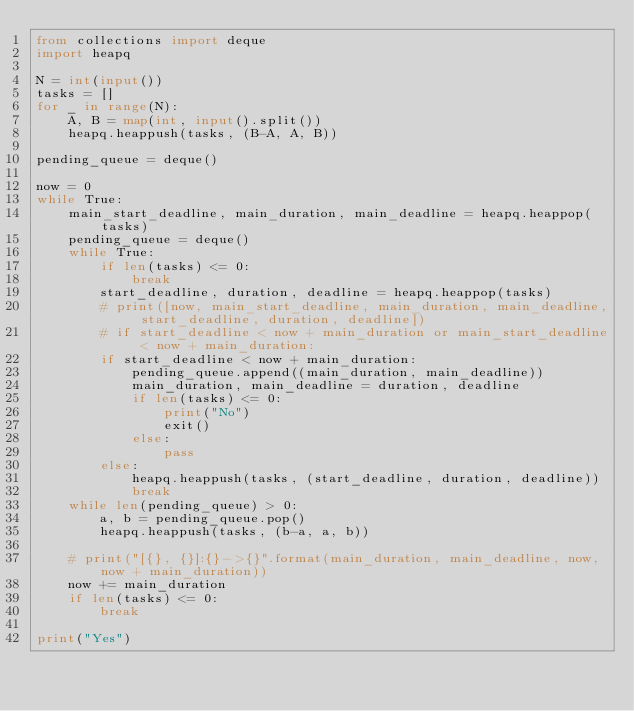<code> <loc_0><loc_0><loc_500><loc_500><_Python_>from collections import deque
import heapq

N = int(input())
tasks = []
for _ in range(N):
    A, B = map(int, input().split())
    heapq.heappush(tasks, (B-A, A, B))

pending_queue = deque()

now = 0
while True:
    main_start_deadline, main_duration, main_deadline = heapq.heappop(tasks)
    pending_queue = deque()
    while True:
        if len(tasks) <= 0:
            break
        start_deadline, duration, deadline = heapq.heappop(tasks)
        # print([now, main_start_deadline, main_duration, main_deadline, start_deadline, duration, deadline])
        # if start_deadline < now + main_duration or main_start_deadline < now + main_duration:
        if start_deadline < now + main_duration:
            pending_queue.append((main_duration, main_deadline))
            main_duration, main_deadline = duration, deadline
            if len(tasks) <= 0:
                print("No")
                exit()
            else:
                pass
        else:
            heapq.heappush(tasks, (start_deadline, duration, deadline))
            break
    while len(pending_queue) > 0:
        a, b = pending_queue.pop()
        heapq.heappush(tasks, (b-a, a, b))
            
    # print("[{}, {}]:{}->{}".format(main_duration, main_deadline, now, now + main_duration))
    now += main_duration
    if len(tasks) <= 0:
        break

print("Yes")
</code> 